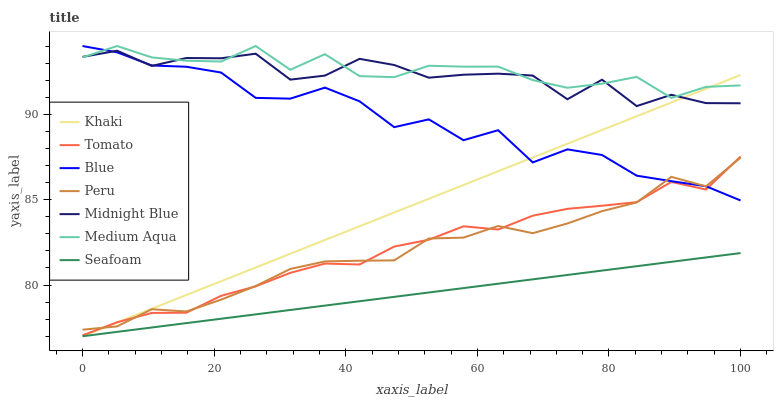Does Seafoam have the minimum area under the curve?
Answer yes or no. Yes. Does Medium Aqua have the maximum area under the curve?
Answer yes or no. Yes. Does Blue have the minimum area under the curve?
Answer yes or no. No. Does Blue have the maximum area under the curve?
Answer yes or no. No. Is Khaki the smoothest?
Answer yes or no. Yes. Is Midnight Blue the roughest?
Answer yes or no. Yes. Is Blue the smoothest?
Answer yes or no. No. Is Blue the roughest?
Answer yes or no. No. Does Khaki have the lowest value?
Answer yes or no. Yes. Does Blue have the lowest value?
Answer yes or no. No. Does Medium Aqua have the highest value?
Answer yes or no. Yes. Does Khaki have the highest value?
Answer yes or no. No. Is Tomato less than Medium Aqua?
Answer yes or no. Yes. Is Midnight Blue greater than Peru?
Answer yes or no. Yes. Does Medium Aqua intersect Blue?
Answer yes or no. Yes. Is Medium Aqua less than Blue?
Answer yes or no. No. Is Medium Aqua greater than Blue?
Answer yes or no. No. Does Tomato intersect Medium Aqua?
Answer yes or no. No. 